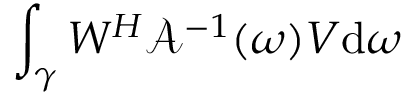<formula> <loc_0><loc_0><loc_500><loc_500>\int _ { \gamma } W ^ { H } \mathcal { A } ^ { - 1 } ( \omega ) V d \omega</formula> 